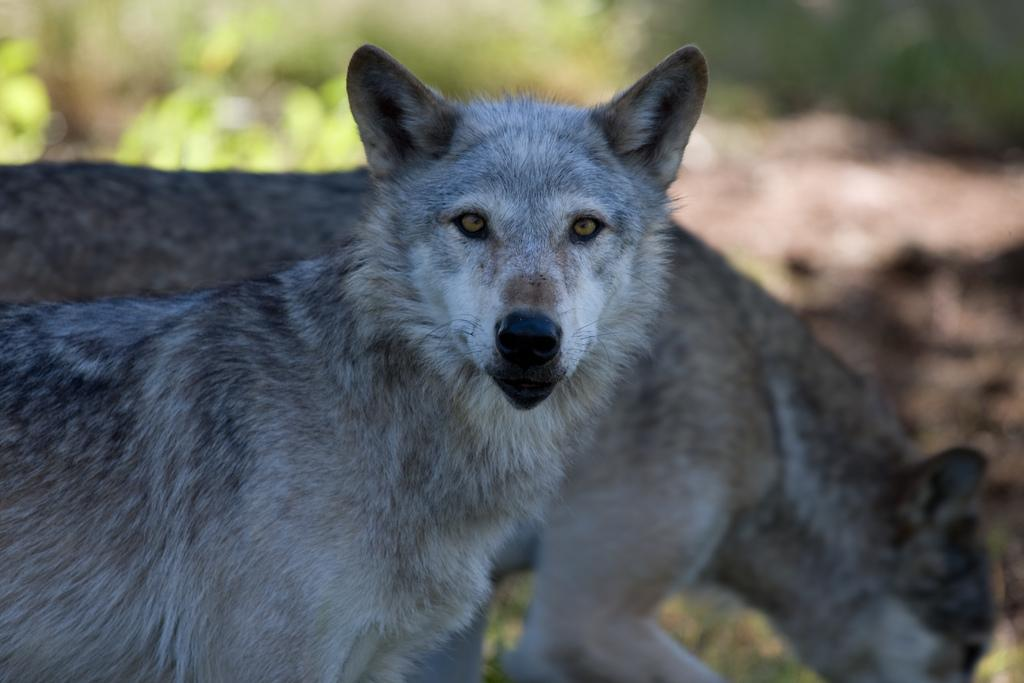What types of living organisms can be seen in the image? There are animals in the image. What can be observed about the background of the image? The background of the image is blurred. Can you describe any objects visible in the background? Yes, there are objects visible in the background of the image. What type of hole can be seen in the image? There is no hole present in the image. What drink is being consumed by the animals in the image? There are no animals consuming any drinks in the image. 